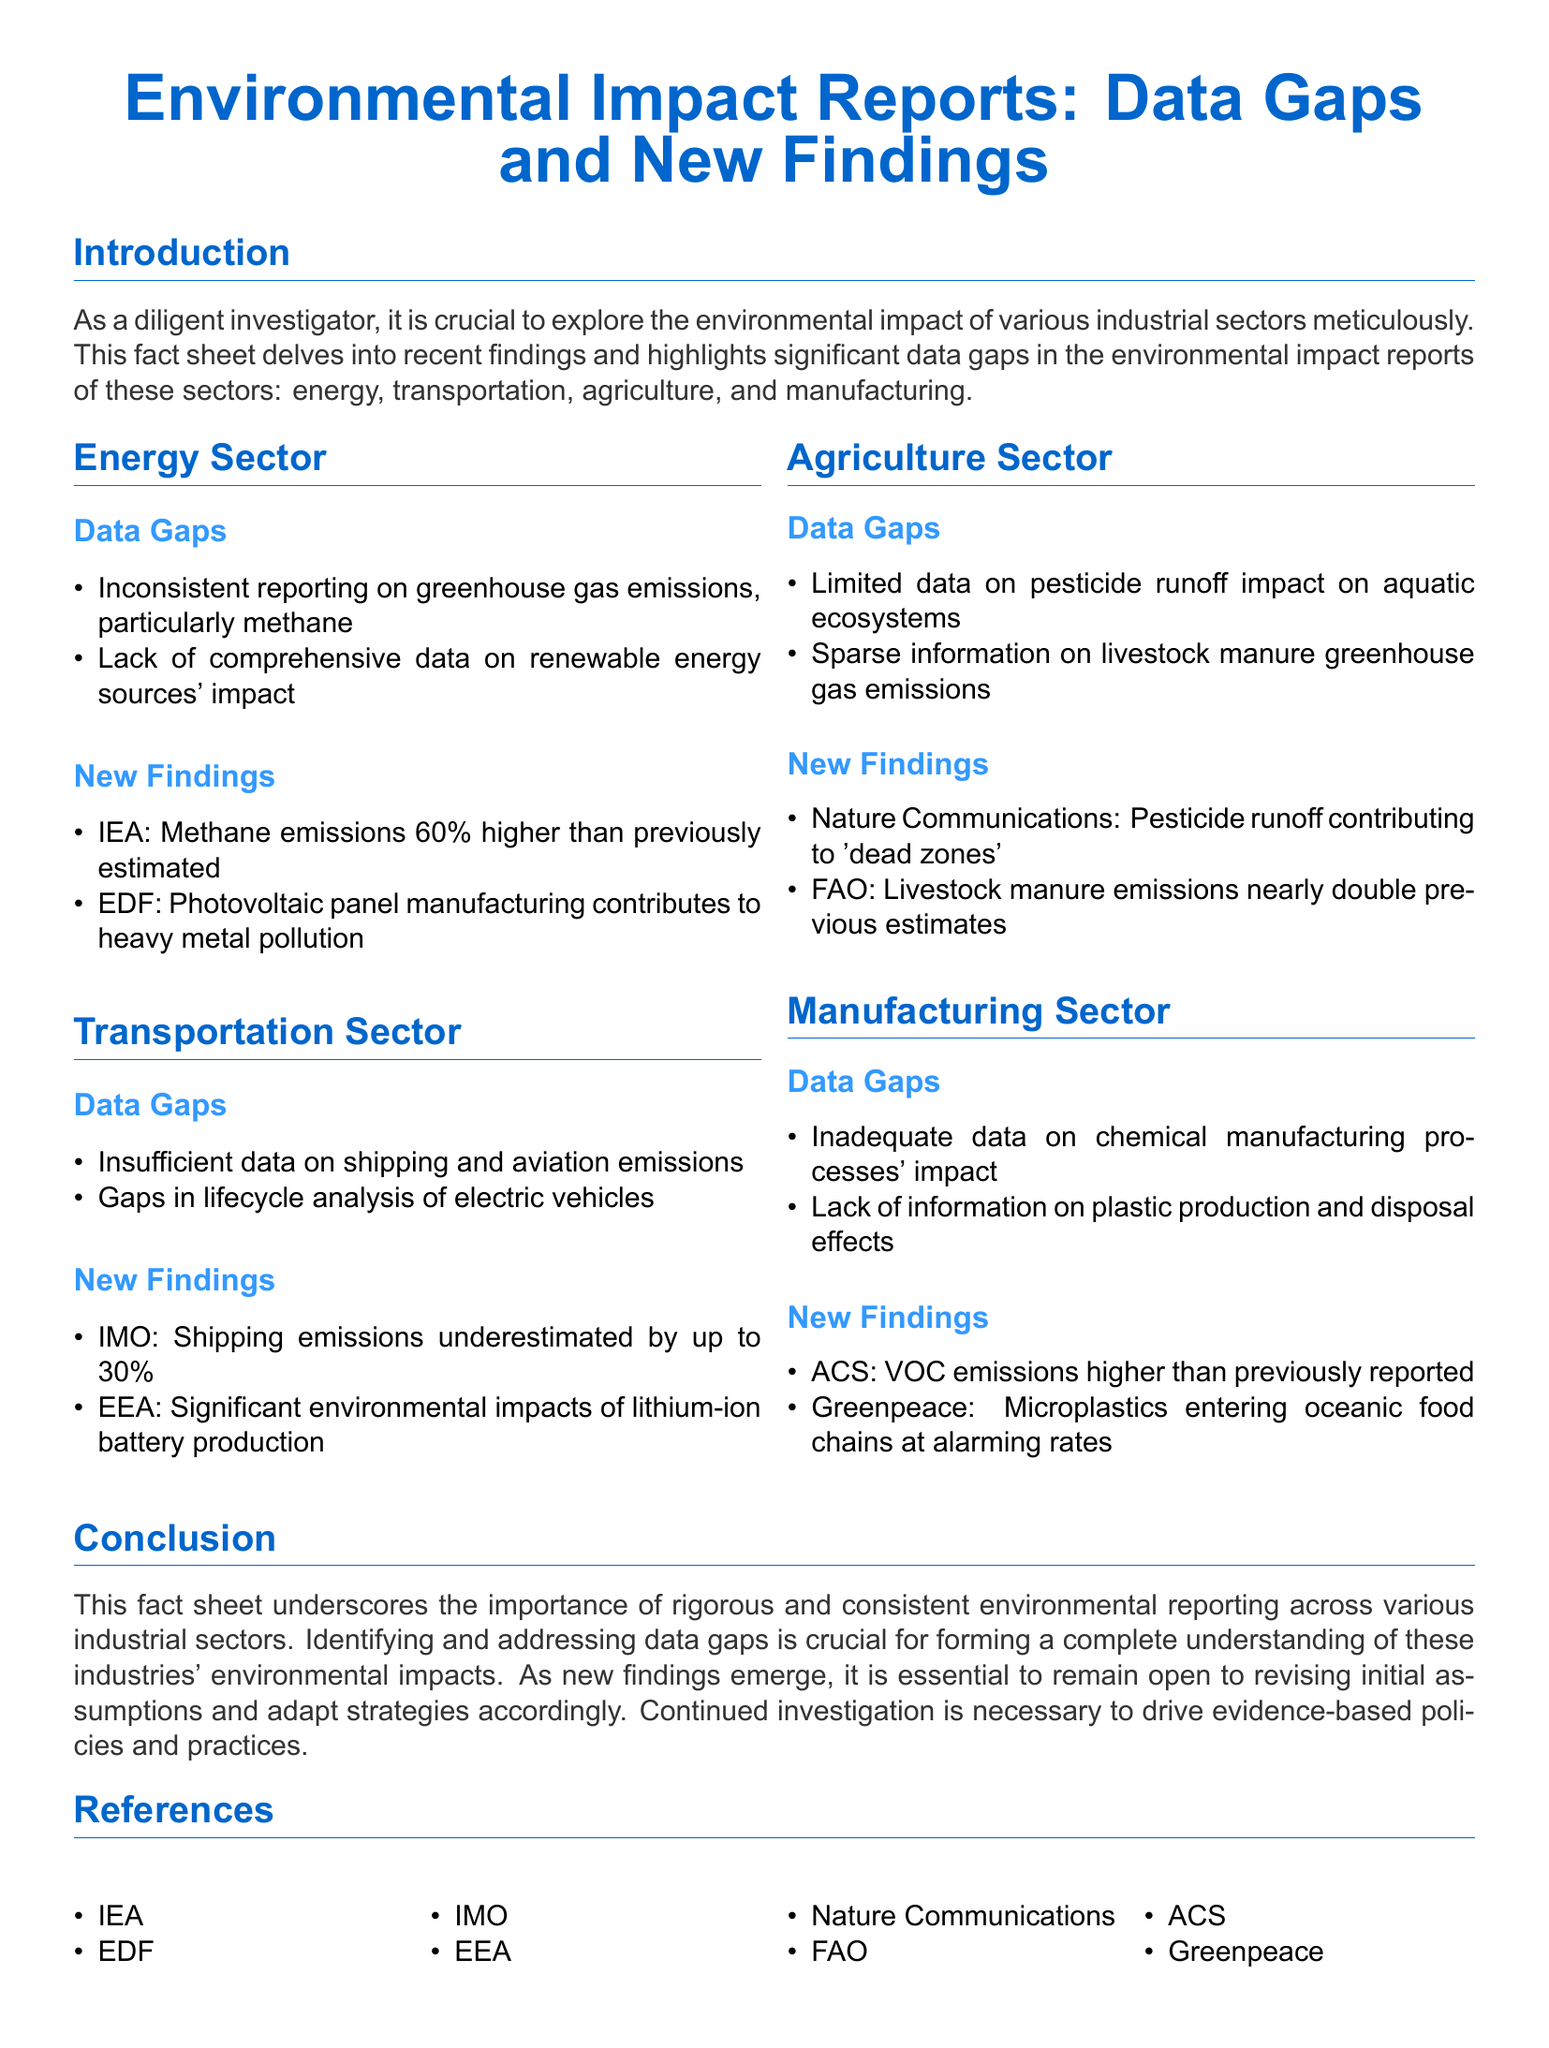what is the focus of the fact sheet? The focus of the fact sheet is on environmental impact reports with an emphasis on data gaps and new findings across different industrial sectors.
Answer: environmental impact reports: data gaps and new findings which sector is associated with high methane emissions estimates? The data indicates that methane emissions in the energy sector are significantly underestimated.
Answer: energy sector how much higher are methane emissions than previously estimated according to IEA? The IEA states that methane emissions are 60% higher than previously estimated.
Answer: 60% what significant environmental impact is associated with lithium-ion battery production? The environmental impact declaration emphasizes significant effects stemming from lithium-ion battery production in the transportation sector.
Answer: significant environmental impacts what issue is highlighted regarding pesticide runoff in agriculture? The document indicates that pesticide runoff contributes to 'dead zones,' showcasing a major environmental issue.
Answer: contributing to 'dead zones' how are VOC emissions characterized in the manufacturing sector? The document states that VOC emissions are higher than previously reported, indicating a data gap concern.
Answer: higher than previously reported what common theme is found in all reported sectors? A recurring theme throughout the fact sheet is the notable presence of data gaps in the environmental impact reports across all sectors.
Answer: data gaps which organization reported on the shipping emissions underestimation? The report highlights findings from the IMO regarding shipping emissions.
Answer: IMO what is emphasized as essential for forming a complete understanding of environmental impacts? The importance of identifying and addressing data gaps is emphasized for achieving a comprehensive understanding of environmental impacts.
Answer: identifying and addressing data gaps 